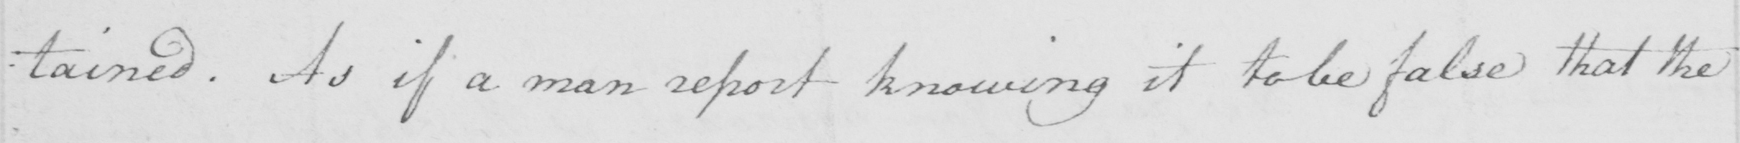Can you tell me what this handwritten text says? : tained . As if a man report knowing it to be false that the 